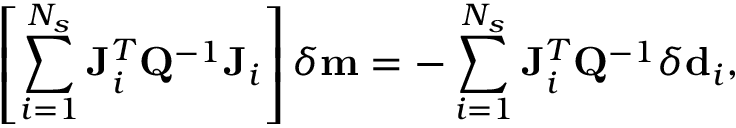<formula> <loc_0><loc_0><loc_500><loc_500>\left [ \sum _ { i = 1 } ^ { N _ { s } } J _ { i } ^ { T } Q ^ { - 1 } J _ { i } \right ] \delta m = - \sum _ { i = 1 } ^ { N _ { s } } J _ { i } ^ { T } Q ^ { - 1 } \delta d _ { i } ,</formula> 